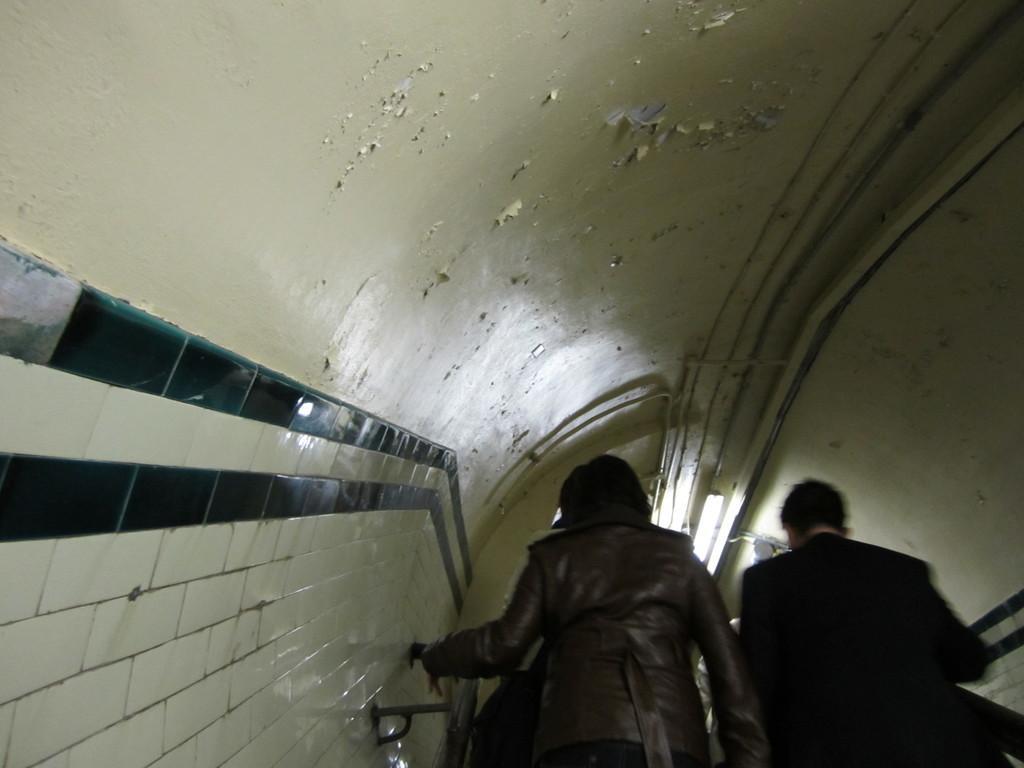Could you give a brief overview of what you see in this image? In this picture there is a woman who is wearing jacket, beside her i can see a man who is wearing black blazer. Both of them were standing near to the stairs and holding the railing. In front of them i can see the tube light. 